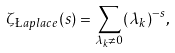<formula> <loc_0><loc_0><loc_500><loc_500>\zeta _ { \L a p l a c e } ( s ) = \sum _ { \lambda _ { k } \neq 0 } ( \lambda _ { k } ) ^ { - s } ,</formula> 